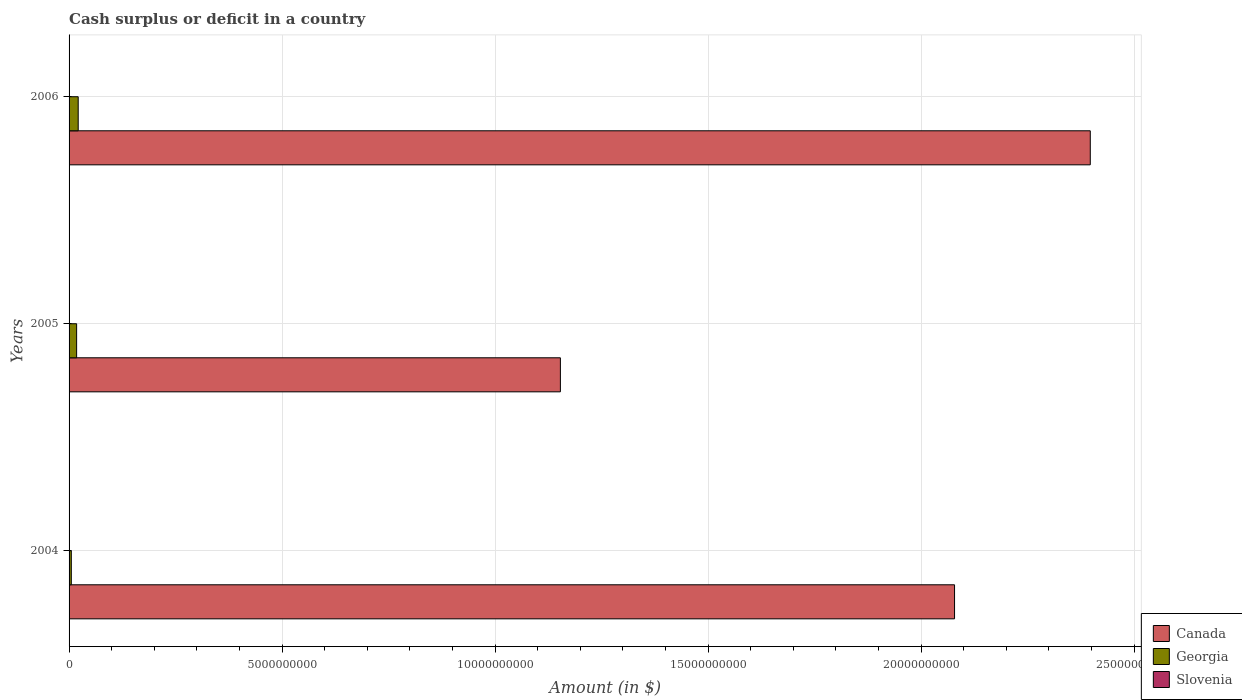Are the number of bars on each tick of the Y-axis equal?
Your answer should be compact. Yes. How many bars are there on the 2nd tick from the top?
Make the answer very short. 2. How many bars are there on the 3rd tick from the bottom?
Keep it short and to the point. 2. In how many cases, is the number of bars for a given year not equal to the number of legend labels?
Ensure brevity in your answer.  3. What is the amount of cash surplus or deficit in Canada in 2005?
Your answer should be very brief. 1.15e+1. Across all years, what is the maximum amount of cash surplus or deficit in Georgia?
Give a very brief answer. 2.14e+08. Across all years, what is the minimum amount of cash surplus or deficit in Slovenia?
Ensure brevity in your answer.  0. What is the total amount of cash surplus or deficit in Slovenia in the graph?
Your response must be concise. 0. What is the difference between the amount of cash surplus or deficit in Canada in 2004 and that in 2005?
Keep it short and to the point. 9.25e+09. What is the difference between the amount of cash surplus or deficit in Georgia in 2006 and the amount of cash surplus or deficit in Slovenia in 2005?
Provide a short and direct response. 2.14e+08. What is the average amount of cash surplus or deficit in Slovenia per year?
Ensure brevity in your answer.  0. In the year 2006, what is the difference between the amount of cash surplus or deficit in Canada and amount of cash surplus or deficit in Georgia?
Make the answer very short. 2.38e+1. What is the ratio of the amount of cash surplus or deficit in Canada in 2005 to that in 2006?
Ensure brevity in your answer.  0.48. Is the amount of cash surplus or deficit in Canada in 2005 less than that in 2006?
Ensure brevity in your answer.  Yes. What is the difference between the highest and the second highest amount of cash surplus or deficit in Georgia?
Make the answer very short. 3.73e+07. What is the difference between the highest and the lowest amount of cash surplus or deficit in Canada?
Your answer should be very brief. 1.24e+1. In how many years, is the amount of cash surplus or deficit in Georgia greater than the average amount of cash surplus or deficit in Georgia taken over all years?
Your answer should be very brief. 2. Is the sum of the amount of cash surplus or deficit in Georgia in 2004 and 2005 greater than the maximum amount of cash surplus or deficit in Slovenia across all years?
Provide a short and direct response. Yes. How many bars are there?
Keep it short and to the point. 6. Are all the bars in the graph horizontal?
Your response must be concise. Yes. How many years are there in the graph?
Your response must be concise. 3. What is the difference between two consecutive major ticks on the X-axis?
Your answer should be compact. 5.00e+09. Does the graph contain grids?
Your answer should be very brief. Yes. Where does the legend appear in the graph?
Your answer should be very brief. Bottom right. How many legend labels are there?
Your answer should be compact. 3. How are the legend labels stacked?
Offer a terse response. Vertical. What is the title of the graph?
Make the answer very short. Cash surplus or deficit in a country. Does "Virgin Islands" appear as one of the legend labels in the graph?
Provide a succinct answer. No. What is the label or title of the X-axis?
Ensure brevity in your answer.  Amount (in $). What is the Amount (in $) of Canada in 2004?
Offer a very short reply. 2.08e+1. What is the Amount (in $) of Georgia in 2004?
Provide a short and direct response. 5.26e+07. What is the Amount (in $) in Canada in 2005?
Offer a very short reply. 1.15e+1. What is the Amount (in $) of Georgia in 2005?
Your response must be concise. 1.77e+08. What is the Amount (in $) of Slovenia in 2005?
Offer a terse response. 0. What is the Amount (in $) in Canada in 2006?
Ensure brevity in your answer.  2.40e+1. What is the Amount (in $) of Georgia in 2006?
Ensure brevity in your answer.  2.14e+08. What is the Amount (in $) of Slovenia in 2006?
Keep it short and to the point. 0. Across all years, what is the maximum Amount (in $) of Canada?
Your response must be concise. 2.40e+1. Across all years, what is the maximum Amount (in $) in Georgia?
Keep it short and to the point. 2.14e+08. Across all years, what is the minimum Amount (in $) in Canada?
Ensure brevity in your answer.  1.15e+1. Across all years, what is the minimum Amount (in $) of Georgia?
Provide a succinct answer. 5.26e+07. What is the total Amount (in $) of Canada in the graph?
Your response must be concise. 5.63e+1. What is the total Amount (in $) in Georgia in the graph?
Offer a terse response. 4.44e+08. What is the total Amount (in $) of Slovenia in the graph?
Give a very brief answer. 0. What is the difference between the Amount (in $) of Canada in 2004 and that in 2005?
Give a very brief answer. 9.25e+09. What is the difference between the Amount (in $) of Georgia in 2004 and that in 2005?
Your answer should be compact. -1.25e+08. What is the difference between the Amount (in $) in Canada in 2004 and that in 2006?
Offer a terse response. -3.19e+09. What is the difference between the Amount (in $) in Georgia in 2004 and that in 2006?
Offer a terse response. -1.62e+08. What is the difference between the Amount (in $) in Canada in 2005 and that in 2006?
Provide a short and direct response. -1.24e+1. What is the difference between the Amount (in $) in Georgia in 2005 and that in 2006?
Offer a very short reply. -3.73e+07. What is the difference between the Amount (in $) in Canada in 2004 and the Amount (in $) in Georgia in 2005?
Provide a short and direct response. 2.06e+1. What is the difference between the Amount (in $) of Canada in 2004 and the Amount (in $) of Georgia in 2006?
Ensure brevity in your answer.  2.06e+1. What is the difference between the Amount (in $) in Canada in 2005 and the Amount (in $) in Georgia in 2006?
Your response must be concise. 1.13e+1. What is the average Amount (in $) of Canada per year?
Keep it short and to the point. 1.88e+1. What is the average Amount (in $) in Georgia per year?
Make the answer very short. 1.48e+08. In the year 2004, what is the difference between the Amount (in $) of Canada and Amount (in $) of Georgia?
Keep it short and to the point. 2.07e+1. In the year 2005, what is the difference between the Amount (in $) in Canada and Amount (in $) in Georgia?
Provide a short and direct response. 1.14e+1. In the year 2006, what is the difference between the Amount (in $) of Canada and Amount (in $) of Georgia?
Give a very brief answer. 2.38e+1. What is the ratio of the Amount (in $) of Canada in 2004 to that in 2005?
Your response must be concise. 1.8. What is the ratio of the Amount (in $) of Georgia in 2004 to that in 2005?
Make the answer very short. 0.3. What is the ratio of the Amount (in $) in Canada in 2004 to that in 2006?
Give a very brief answer. 0.87. What is the ratio of the Amount (in $) of Georgia in 2004 to that in 2006?
Your answer should be compact. 0.25. What is the ratio of the Amount (in $) of Canada in 2005 to that in 2006?
Provide a succinct answer. 0.48. What is the ratio of the Amount (in $) of Georgia in 2005 to that in 2006?
Provide a succinct answer. 0.83. What is the difference between the highest and the second highest Amount (in $) of Canada?
Make the answer very short. 3.19e+09. What is the difference between the highest and the second highest Amount (in $) in Georgia?
Give a very brief answer. 3.73e+07. What is the difference between the highest and the lowest Amount (in $) of Canada?
Offer a terse response. 1.24e+1. What is the difference between the highest and the lowest Amount (in $) in Georgia?
Offer a very short reply. 1.62e+08. 